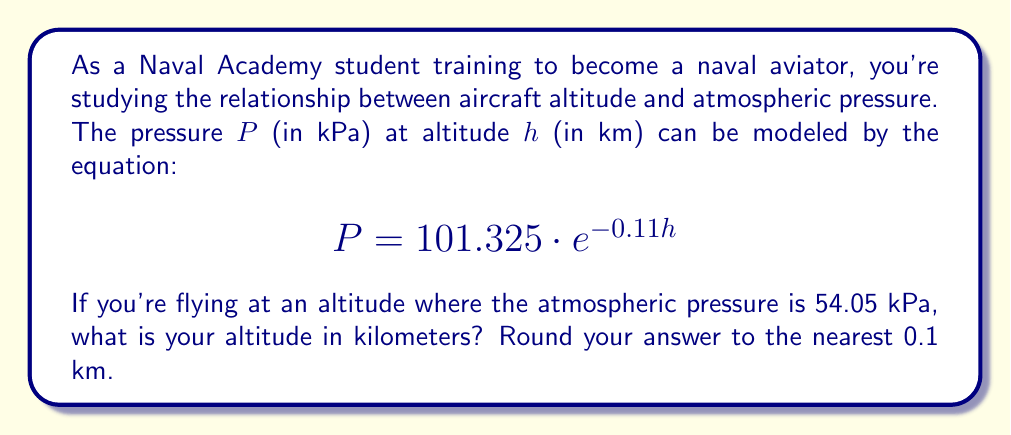Help me with this question. Let's approach this step-by-step using logarithmic properties:

1) We start with the given equation:
   $$P = 101.325 \cdot e^{-0.11h}$$

2) We know that $P = 54.05$ kPa. Let's substitute this:
   $$54.05 = 101.325 \cdot e^{-0.11h}$$

3) To isolate $h$, we first divide both sides by 101.325:
   $$\frac{54.05}{101.325} = e^{-0.11h}$$

4) This simplifies to:
   $$0.5334 = e^{-0.11h}$$

5) Now, we can take the natural logarithm of both sides. Remember, $\ln(e^x) = x$:
   $$\ln(0.5334) = \ln(e^{-0.11h})$$
   $$\ln(0.5334) = -0.11h$$

6) Divide both sides by -0.11 to isolate $h$:
   $$\frac{\ln(0.5334)}{-0.11} = h$$

7) Calculate this value:
   $$h = \frac{-0.6284}{-0.11} \approx 5.7127 \text{ km}$$

8) Rounding to the nearest 0.1 km:
   $$h \approx 5.7 \text{ km}$$
Answer: $5.7$ km 